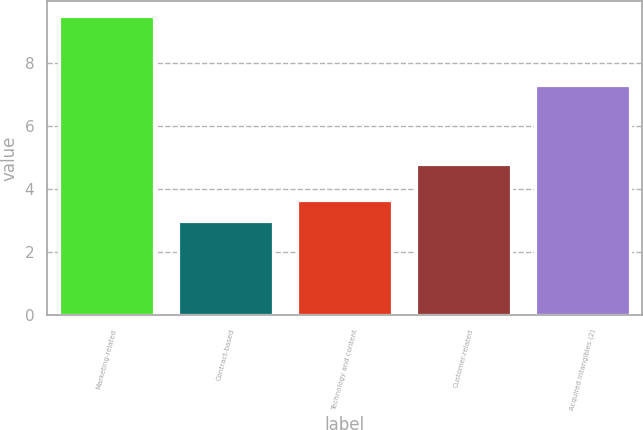Convert chart to OTSL. <chart><loc_0><loc_0><loc_500><loc_500><bar_chart><fcel>Marketing-related<fcel>Contract-based<fcel>Technology and content<fcel>Customer-related<fcel>Acquired intangibles (2)<nl><fcel>9.5<fcel>3<fcel>3.65<fcel>4.8<fcel>7.3<nl></chart> 